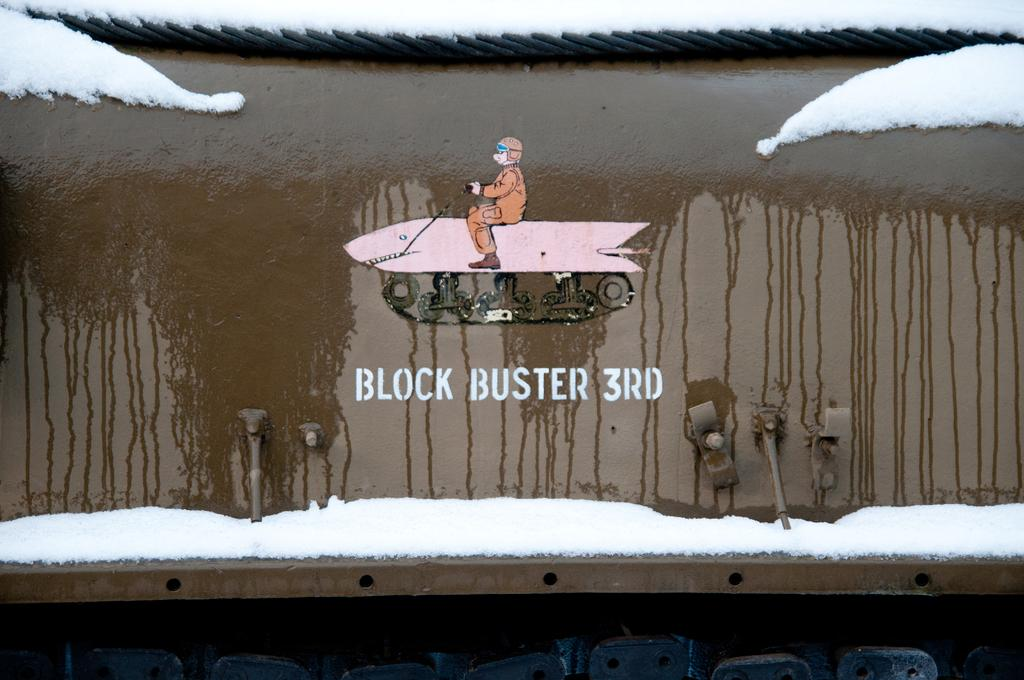Provide a one-sentence caption for the provided image. a sign on a train car reads Block Buster 3rd. 